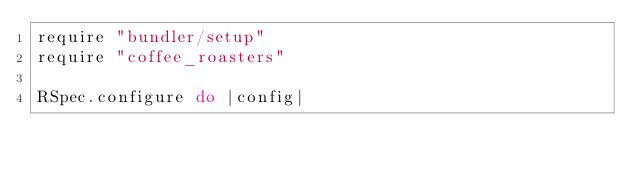<code> <loc_0><loc_0><loc_500><loc_500><_Ruby_>require "bundler/setup"
require "coffee_roasters"

RSpec.configure do |config|</code> 